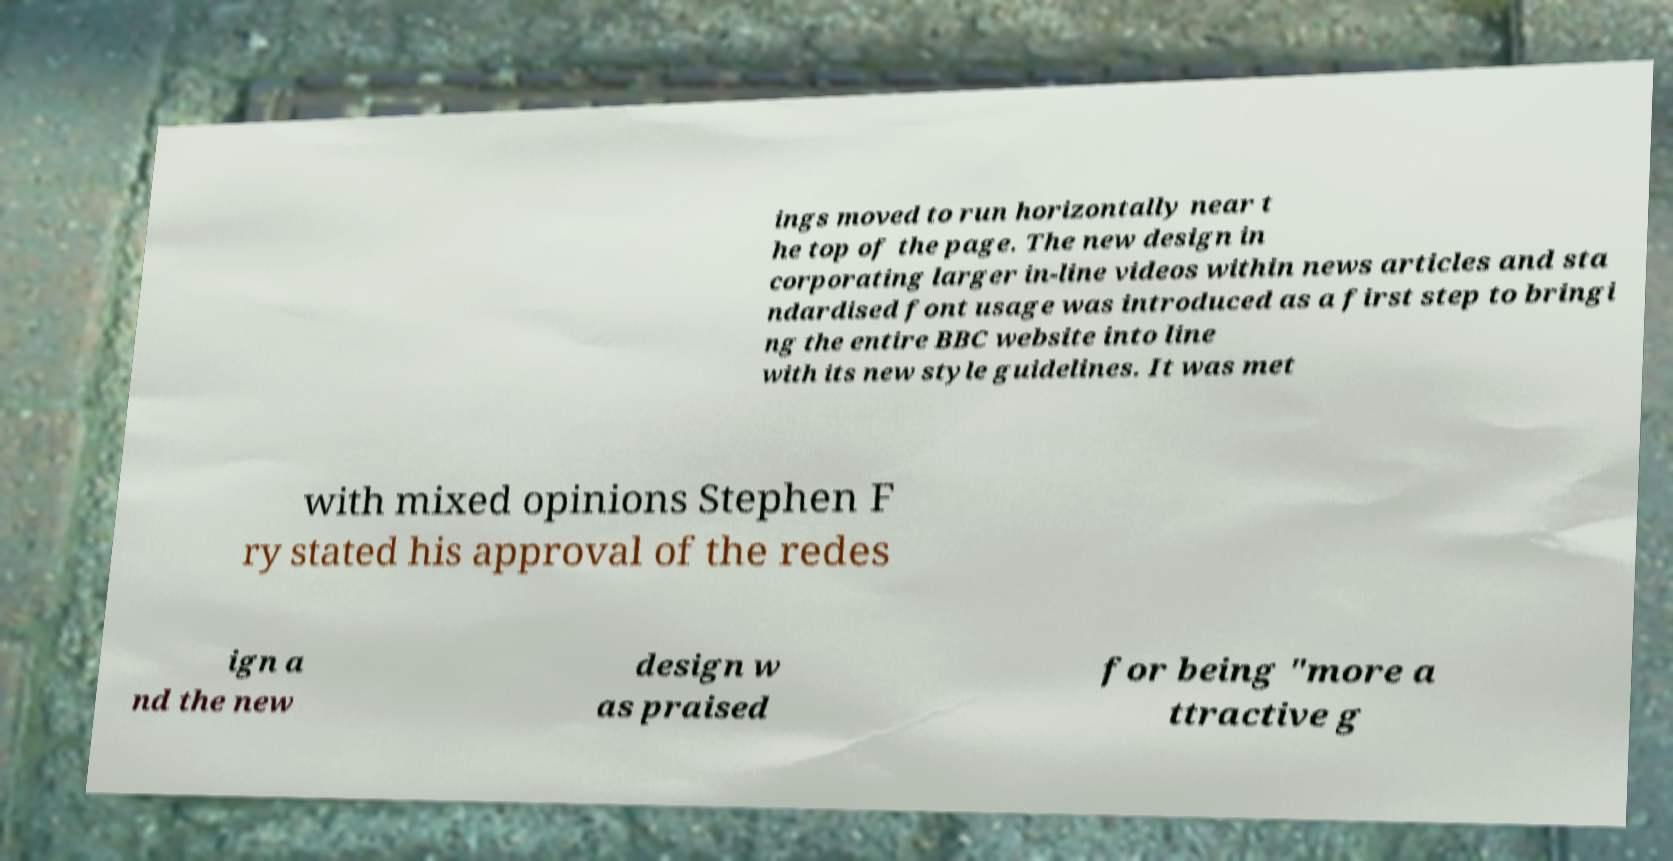There's text embedded in this image that I need extracted. Can you transcribe it verbatim? ings moved to run horizontally near t he top of the page. The new design in corporating larger in-line videos within news articles and sta ndardised font usage was introduced as a first step to bringi ng the entire BBC website into line with its new style guidelines. It was met with mixed opinions Stephen F ry stated his approval of the redes ign a nd the new design w as praised for being "more a ttractive g 